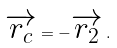Convert formula to latex. <formula><loc_0><loc_0><loc_500><loc_500>\overrightarrow { r _ { c } } = - \overrightarrow { r _ { 2 } } \, .</formula> 